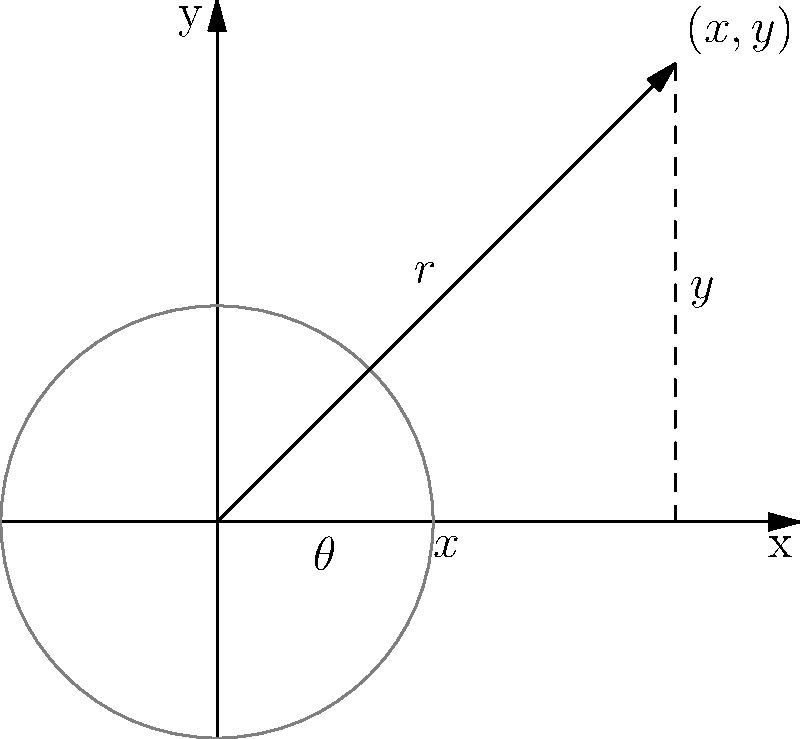In Go, when converting from polar coordinates $(r,\theta)$ to Cartesian coordinates $(x,y)$, which of the following optimizations would likely result in the most significant performance improvement?

A) Using the `math.Sincos` function instead of separate `math.Sin` and `math.Cos` calls
B) Precomputing common values of sine and cosine
C) Using fixed-point arithmetic instead of floating-point
D) Implementing a custom approximation of sine and cosine functions To optimize the conversion from polar coordinates $(r,\theta)$ to Cartesian coordinates $(x,y)$ in Go, we need to consider several factors:

1. The standard conversion formulas are:
   $$x = r \cos(\theta)$$
   $$y = r \sin(\theta)$$

2. In Go, these calculations typically use the `math.Sin` and `math.Cos` functions, which are relatively expensive operations.

3. Option A suggests using `math.Sincos`, which computes both sine and cosine simultaneously. This is more efficient than separate calls because:
   - It reduces function call overhead
   - It can utilize CPU-specific optimizations for computing both values at once

4. Option B (precomputing values) can be efficient for a limited set of angles but isn't generally applicable for arbitrary input.

5. Option C (fixed-point arithmetic) can be faster in some cases but may sacrifice accuracy and isn't always suitable for general-purpose calculations.

6. Option D (custom approximations) could potentially be faster but would require careful implementation and testing to ensure accuracy.

7. Among these options, A provides the best balance of performance improvement, accuracy, and ease of implementation for general use in Go programs.

Therefore, using `math.Sincos` is likely to provide the most significant and broadly applicable performance improvement for this conversion in Go.
Answer: Using the `math.Sincos` function 